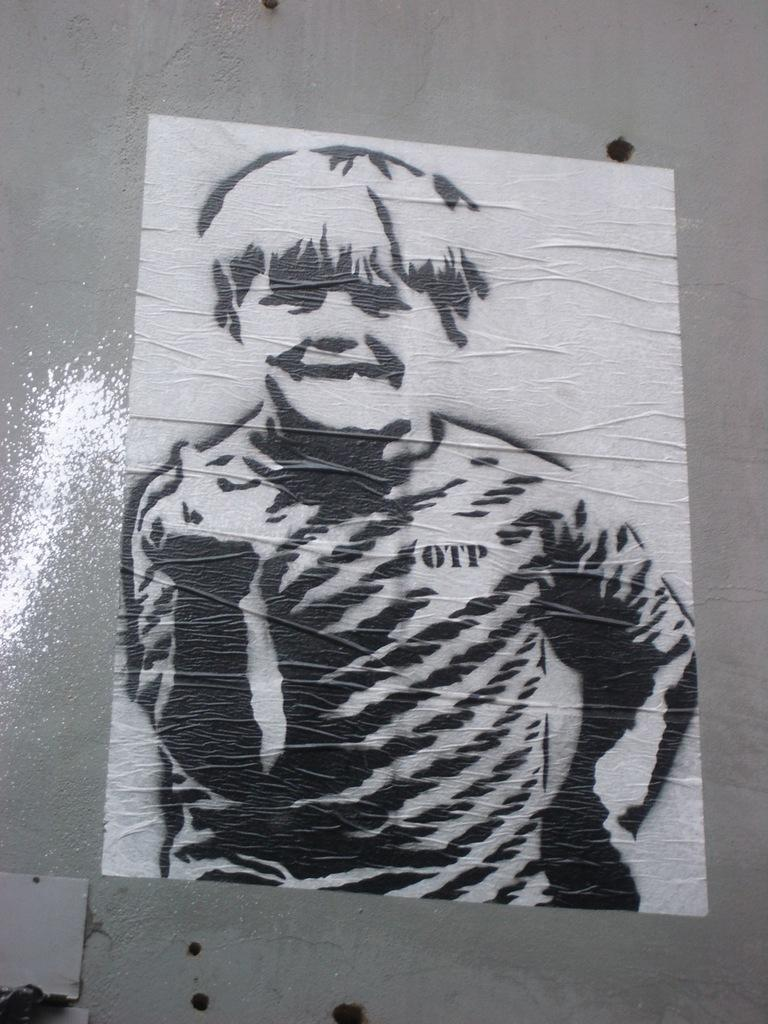What is hanging on the wall in the image? There is a painting on the wall in the image. What type of bells can be heard ringing in the image? There are no bells present in the image, and therefore no sounds can be heard. 